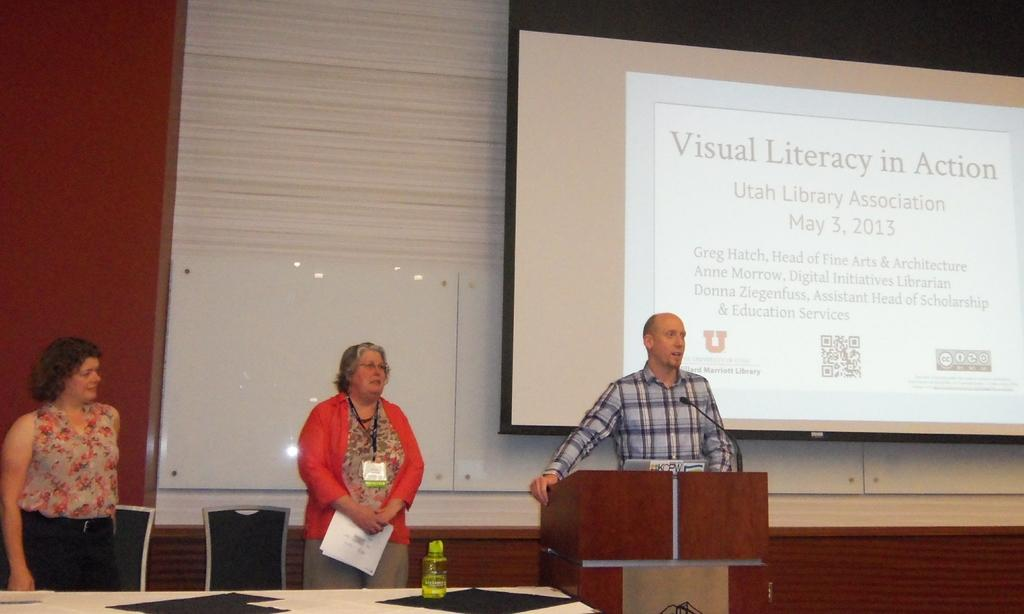What is the person in the image doing? The person is standing in front of a wooden desk and speaking on a microphone. Are there any other people in the image? Yes, there are two women standing on the left side. What might be used for displaying information or visuals in the image? There is a screen present in the image. Can you see a robin perched on the microphone in the image? No, there is no robin present in the image. Is the person's dad also in the image? The provided facts do not mention the person's dad, so we cannot determine if he is present in the image. 